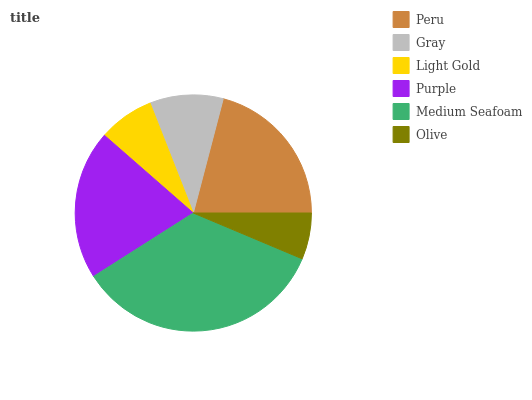Is Olive the minimum?
Answer yes or no. Yes. Is Medium Seafoam the maximum?
Answer yes or no. Yes. Is Gray the minimum?
Answer yes or no. No. Is Gray the maximum?
Answer yes or no. No. Is Peru greater than Gray?
Answer yes or no. Yes. Is Gray less than Peru?
Answer yes or no. Yes. Is Gray greater than Peru?
Answer yes or no. No. Is Peru less than Gray?
Answer yes or no. No. Is Purple the high median?
Answer yes or no. Yes. Is Gray the low median?
Answer yes or no. Yes. Is Gray the high median?
Answer yes or no. No. Is Medium Seafoam the low median?
Answer yes or no. No. 